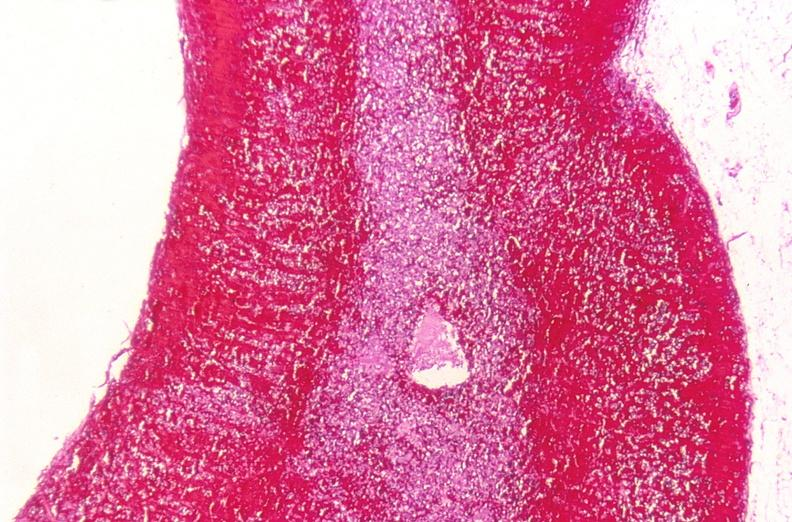s side present?
Answer the question using a single word or phrase. No 